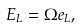Convert formula to latex. <formula><loc_0><loc_0><loc_500><loc_500>E _ { L } = \Omega e _ { L } ,</formula> 